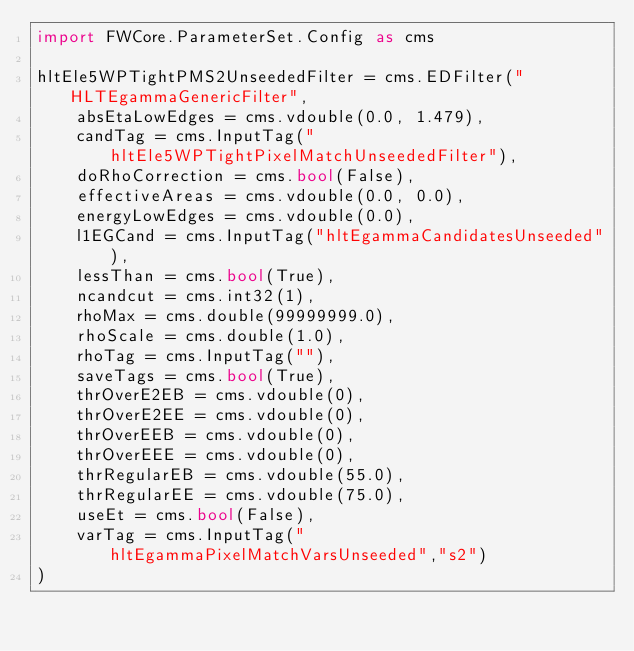Convert code to text. <code><loc_0><loc_0><loc_500><loc_500><_Python_>import FWCore.ParameterSet.Config as cms

hltEle5WPTightPMS2UnseededFilter = cms.EDFilter("HLTEgammaGenericFilter",
    absEtaLowEdges = cms.vdouble(0.0, 1.479),
    candTag = cms.InputTag("hltEle5WPTightPixelMatchUnseededFilter"),
    doRhoCorrection = cms.bool(False),
    effectiveAreas = cms.vdouble(0.0, 0.0),
    energyLowEdges = cms.vdouble(0.0),
    l1EGCand = cms.InputTag("hltEgammaCandidatesUnseeded"),
    lessThan = cms.bool(True),
    ncandcut = cms.int32(1),
    rhoMax = cms.double(99999999.0),
    rhoScale = cms.double(1.0),
    rhoTag = cms.InputTag(""),
    saveTags = cms.bool(True),
    thrOverE2EB = cms.vdouble(0),
    thrOverE2EE = cms.vdouble(0),
    thrOverEEB = cms.vdouble(0),
    thrOverEEE = cms.vdouble(0),
    thrRegularEB = cms.vdouble(55.0),
    thrRegularEE = cms.vdouble(75.0),
    useEt = cms.bool(False),
    varTag = cms.InputTag("hltEgammaPixelMatchVarsUnseeded","s2")
)
</code> 